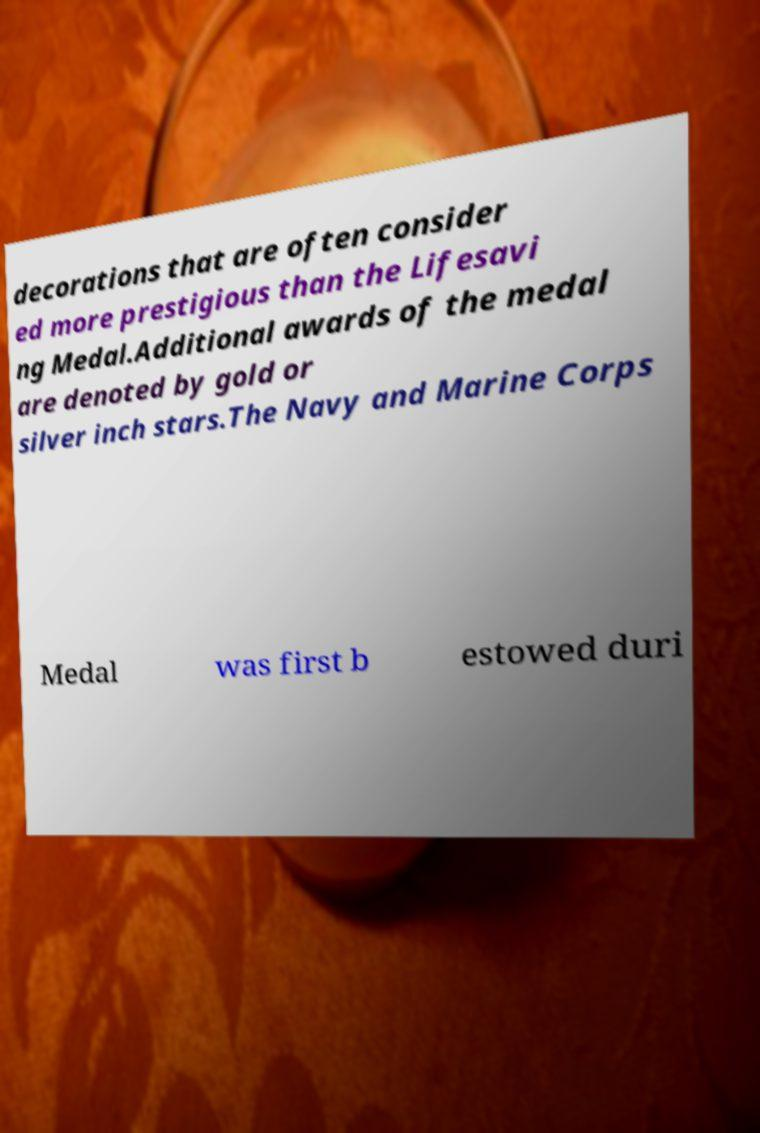Can you accurately transcribe the text from the provided image for me? decorations that are often consider ed more prestigious than the Lifesavi ng Medal.Additional awards of the medal are denoted by gold or silver inch stars.The Navy and Marine Corps Medal was first b estowed duri 